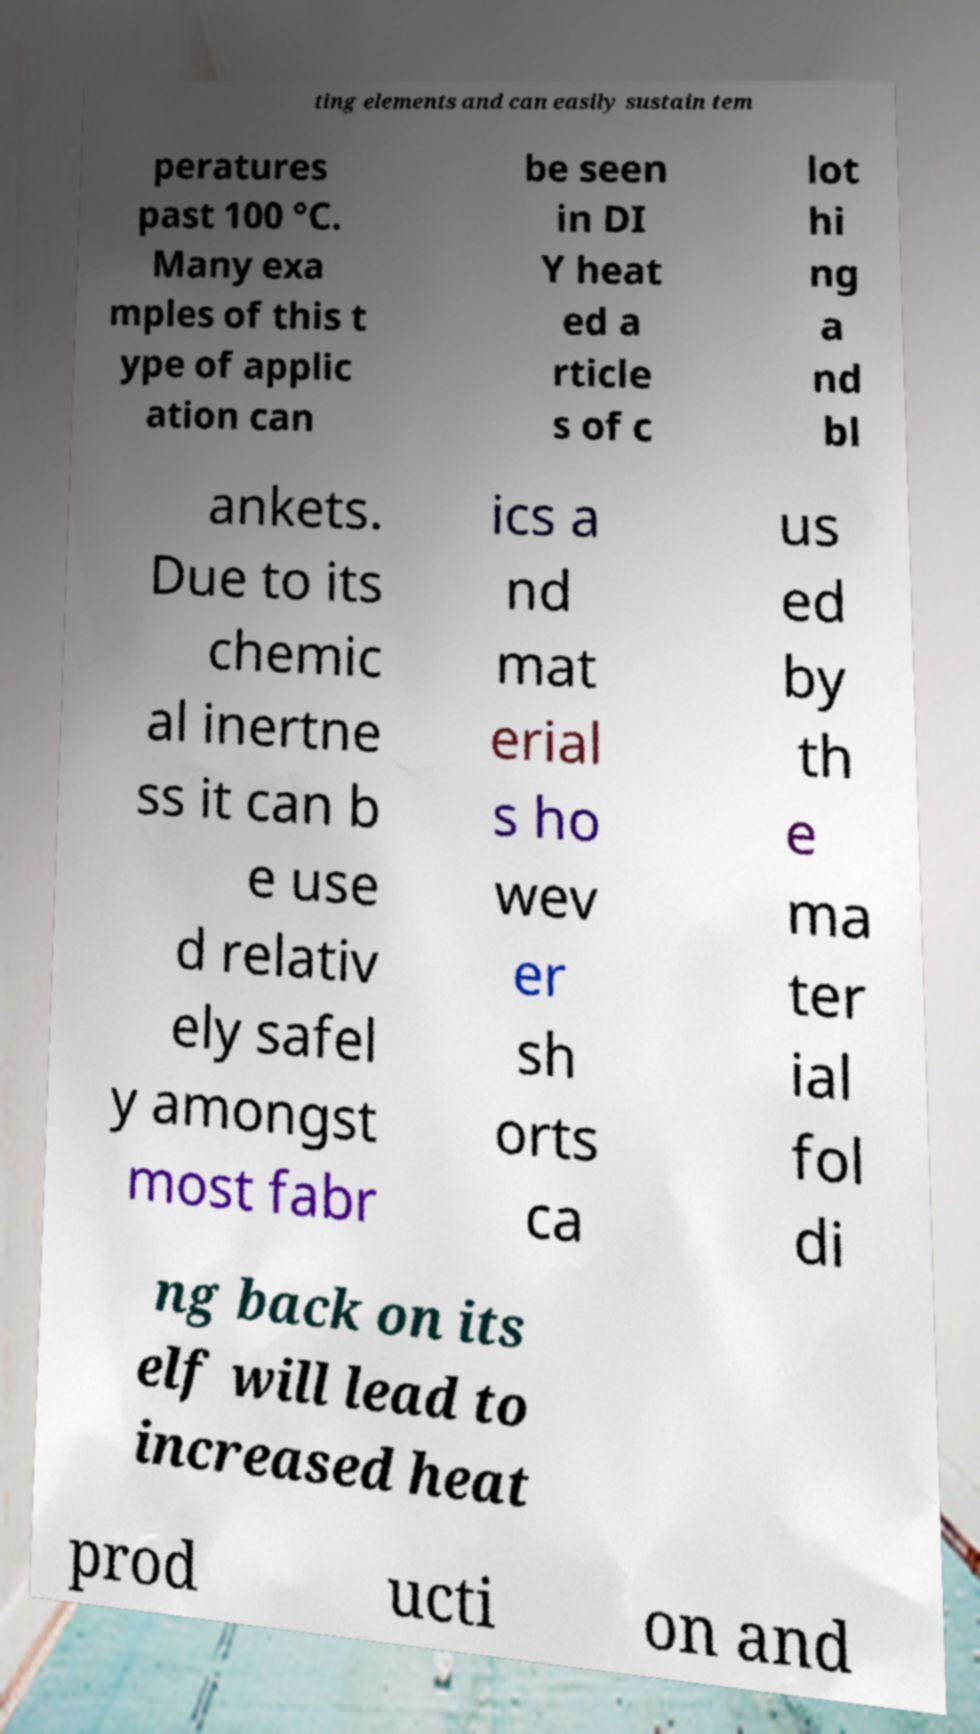I need the written content from this picture converted into text. Can you do that? ting elements and can easily sustain tem peratures past 100 °C. Many exa mples of this t ype of applic ation can be seen in DI Y heat ed a rticle s of c lot hi ng a nd bl ankets. Due to its chemic al inertne ss it can b e use d relativ ely safel y amongst most fabr ics a nd mat erial s ho wev er sh orts ca us ed by th e ma ter ial fol di ng back on its elf will lead to increased heat prod ucti on and 